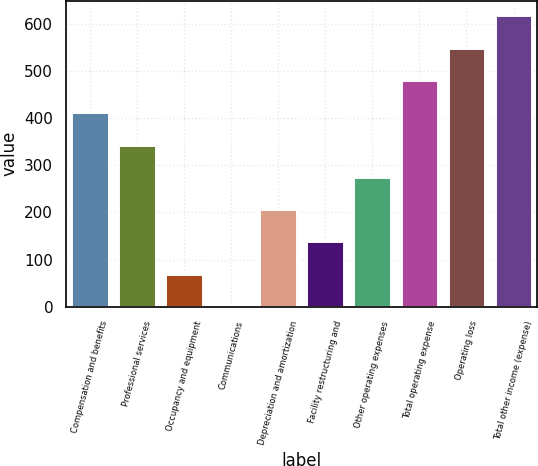Convert chart. <chart><loc_0><loc_0><loc_500><loc_500><bar_chart><fcel>Compensation and benefits<fcel>Professional services<fcel>Occupancy and equipment<fcel>Communications<fcel>Depreciation and amortization<fcel>Facility restructuring and<fcel>Other operating expenses<fcel>Total operating expense<fcel>Operating loss<fcel>Total other income (expense)<nl><fcel>412.4<fcel>343.95<fcel>70.15<fcel>1.7<fcel>207.05<fcel>138.6<fcel>275.5<fcel>480.85<fcel>549.3<fcel>617.75<nl></chart> 